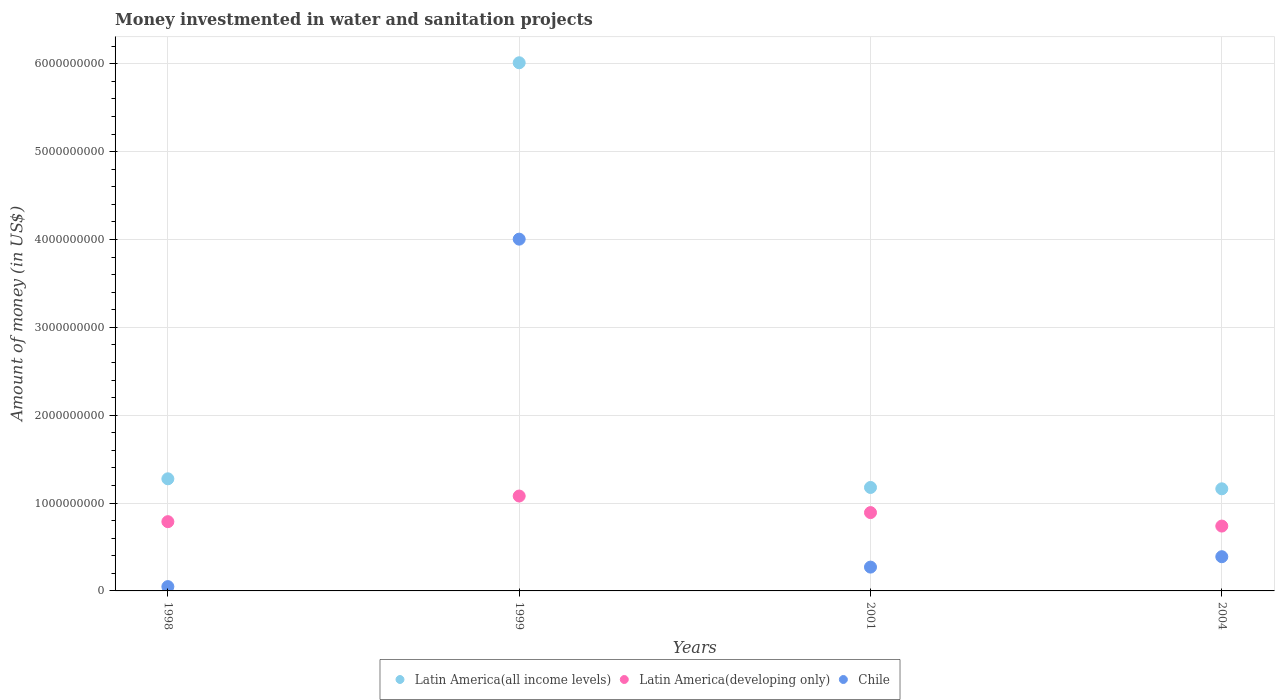How many different coloured dotlines are there?
Make the answer very short. 3. What is the money investmented in water and sanitation projects in Chile in 2001?
Your answer should be compact. 2.71e+08. Across all years, what is the maximum money investmented in water and sanitation projects in Latin America(developing only)?
Offer a very short reply. 1.08e+09. Across all years, what is the minimum money investmented in water and sanitation projects in Chile?
Keep it short and to the point. 4.90e+07. In which year was the money investmented in water and sanitation projects in Chile maximum?
Keep it short and to the point. 1999. In which year was the money investmented in water and sanitation projects in Latin America(all income levels) minimum?
Offer a very short reply. 2004. What is the total money investmented in water and sanitation projects in Latin America(all income levels) in the graph?
Keep it short and to the point. 9.63e+09. What is the difference between the money investmented in water and sanitation projects in Latin America(all income levels) in 1999 and that in 2004?
Provide a short and direct response. 4.85e+09. What is the difference between the money investmented in water and sanitation projects in Latin America(all income levels) in 2004 and the money investmented in water and sanitation projects in Chile in 2001?
Offer a terse response. 8.91e+08. What is the average money investmented in water and sanitation projects in Chile per year?
Provide a short and direct response. 1.18e+09. In the year 2004, what is the difference between the money investmented in water and sanitation projects in Chile and money investmented in water and sanitation projects in Latin America(all income levels)?
Offer a very short reply. -7.73e+08. In how many years, is the money investmented in water and sanitation projects in Latin America(developing only) greater than 6000000000 US$?
Offer a very short reply. 0. What is the ratio of the money investmented in water and sanitation projects in Latin America(developing only) in 2001 to that in 2004?
Keep it short and to the point. 1.21. What is the difference between the highest and the second highest money investmented in water and sanitation projects in Chile?
Offer a terse response. 3.61e+09. What is the difference between the highest and the lowest money investmented in water and sanitation projects in Chile?
Ensure brevity in your answer.  3.95e+09. In how many years, is the money investmented in water and sanitation projects in Latin America(developing only) greater than the average money investmented in water and sanitation projects in Latin America(developing only) taken over all years?
Your answer should be very brief. 2. Is the sum of the money investmented in water and sanitation projects in Latin America(all income levels) in 1999 and 2001 greater than the maximum money investmented in water and sanitation projects in Chile across all years?
Your answer should be very brief. Yes. Is the money investmented in water and sanitation projects in Latin America(developing only) strictly less than the money investmented in water and sanitation projects in Chile over the years?
Keep it short and to the point. No. How many dotlines are there?
Offer a very short reply. 3. What is the difference between two consecutive major ticks on the Y-axis?
Ensure brevity in your answer.  1.00e+09. Does the graph contain any zero values?
Make the answer very short. No. Does the graph contain grids?
Provide a short and direct response. Yes. Where does the legend appear in the graph?
Give a very brief answer. Bottom center. What is the title of the graph?
Provide a short and direct response. Money investmented in water and sanitation projects. What is the label or title of the X-axis?
Offer a very short reply. Years. What is the label or title of the Y-axis?
Make the answer very short. Amount of money (in US$). What is the Amount of money (in US$) of Latin America(all income levels) in 1998?
Provide a short and direct response. 1.28e+09. What is the Amount of money (in US$) of Latin America(developing only) in 1998?
Ensure brevity in your answer.  7.88e+08. What is the Amount of money (in US$) of Chile in 1998?
Offer a terse response. 4.90e+07. What is the Amount of money (in US$) in Latin America(all income levels) in 1999?
Keep it short and to the point. 6.01e+09. What is the Amount of money (in US$) in Latin America(developing only) in 1999?
Make the answer very short. 1.08e+09. What is the Amount of money (in US$) in Chile in 1999?
Offer a terse response. 4.00e+09. What is the Amount of money (in US$) in Latin America(all income levels) in 2001?
Offer a terse response. 1.18e+09. What is the Amount of money (in US$) in Latin America(developing only) in 2001?
Your response must be concise. 8.91e+08. What is the Amount of money (in US$) of Chile in 2001?
Give a very brief answer. 2.71e+08. What is the Amount of money (in US$) of Latin America(all income levels) in 2004?
Ensure brevity in your answer.  1.16e+09. What is the Amount of money (in US$) in Latin America(developing only) in 2004?
Provide a short and direct response. 7.38e+08. What is the Amount of money (in US$) of Chile in 2004?
Provide a succinct answer. 3.89e+08. Across all years, what is the maximum Amount of money (in US$) of Latin America(all income levels)?
Your answer should be very brief. 6.01e+09. Across all years, what is the maximum Amount of money (in US$) in Latin America(developing only)?
Your answer should be very brief. 1.08e+09. Across all years, what is the maximum Amount of money (in US$) of Chile?
Provide a short and direct response. 4.00e+09. Across all years, what is the minimum Amount of money (in US$) of Latin America(all income levels)?
Your answer should be very brief. 1.16e+09. Across all years, what is the minimum Amount of money (in US$) in Latin America(developing only)?
Make the answer very short. 7.38e+08. Across all years, what is the minimum Amount of money (in US$) of Chile?
Provide a short and direct response. 4.90e+07. What is the total Amount of money (in US$) of Latin America(all income levels) in the graph?
Your answer should be compact. 9.63e+09. What is the total Amount of money (in US$) of Latin America(developing only) in the graph?
Ensure brevity in your answer.  3.50e+09. What is the total Amount of money (in US$) in Chile in the graph?
Offer a terse response. 4.71e+09. What is the difference between the Amount of money (in US$) of Latin America(all income levels) in 1998 and that in 1999?
Ensure brevity in your answer.  -4.73e+09. What is the difference between the Amount of money (in US$) in Latin America(developing only) in 1998 and that in 1999?
Your answer should be compact. -2.92e+08. What is the difference between the Amount of money (in US$) of Chile in 1998 and that in 1999?
Offer a terse response. -3.95e+09. What is the difference between the Amount of money (in US$) in Latin America(all income levels) in 1998 and that in 2001?
Your response must be concise. 9.85e+07. What is the difference between the Amount of money (in US$) of Latin America(developing only) in 1998 and that in 2001?
Your answer should be compact. -1.03e+08. What is the difference between the Amount of money (in US$) in Chile in 1998 and that in 2001?
Give a very brief answer. -2.22e+08. What is the difference between the Amount of money (in US$) in Latin America(all income levels) in 1998 and that in 2004?
Offer a terse response. 1.14e+08. What is the difference between the Amount of money (in US$) in Latin America(developing only) in 1998 and that in 2004?
Provide a succinct answer. 5.01e+07. What is the difference between the Amount of money (in US$) of Chile in 1998 and that in 2004?
Offer a very short reply. -3.40e+08. What is the difference between the Amount of money (in US$) in Latin America(all income levels) in 1999 and that in 2001?
Your answer should be very brief. 4.83e+09. What is the difference between the Amount of money (in US$) in Latin America(developing only) in 1999 and that in 2001?
Offer a very short reply. 1.88e+08. What is the difference between the Amount of money (in US$) of Chile in 1999 and that in 2001?
Offer a very short reply. 3.73e+09. What is the difference between the Amount of money (in US$) in Latin America(all income levels) in 1999 and that in 2004?
Give a very brief answer. 4.85e+09. What is the difference between the Amount of money (in US$) in Latin America(developing only) in 1999 and that in 2004?
Your answer should be very brief. 3.42e+08. What is the difference between the Amount of money (in US$) in Chile in 1999 and that in 2004?
Make the answer very short. 3.61e+09. What is the difference between the Amount of money (in US$) of Latin America(all income levels) in 2001 and that in 2004?
Provide a succinct answer. 1.54e+07. What is the difference between the Amount of money (in US$) in Latin America(developing only) in 2001 and that in 2004?
Give a very brief answer. 1.53e+08. What is the difference between the Amount of money (in US$) in Chile in 2001 and that in 2004?
Your answer should be very brief. -1.18e+08. What is the difference between the Amount of money (in US$) in Latin America(all income levels) in 1998 and the Amount of money (in US$) in Latin America(developing only) in 1999?
Ensure brevity in your answer.  1.96e+08. What is the difference between the Amount of money (in US$) of Latin America(all income levels) in 1998 and the Amount of money (in US$) of Chile in 1999?
Give a very brief answer. -2.73e+09. What is the difference between the Amount of money (in US$) of Latin America(developing only) in 1998 and the Amount of money (in US$) of Chile in 1999?
Your response must be concise. -3.22e+09. What is the difference between the Amount of money (in US$) of Latin America(all income levels) in 1998 and the Amount of money (in US$) of Latin America(developing only) in 2001?
Ensure brevity in your answer.  3.84e+08. What is the difference between the Amount of money (in US$) of Latin America(all income levels) in 1998 and the Amount of money (in US$) of Chile in 2001?
Give a very brief answer. 1.00e+09. What is the difference between the Amount of money (in US$) in Latin America(developing only) in 1998 and the Amount of money (in US$) in Chile in 2001?
Offer a very short reply. 5.17e+08. What is the difference between the Amount of money (in US$) in Latin America(all income levels) in 1998 and the Amount of money (in US$) in Latin America(developing only) in 2004?
Your answer should be compact. 5.38e+08. What is the difference between the Amount of money (in US$) of Latin America(all income levels) in 1998 and the Amount of money (in US$) of Chile in 2004?
Ensure brevity in your answer.  8.86e+08. What is the difference between the Amount of money (in US$) of Latin America(developing only) in 1998 and the Amount of money (in US$) of Chile in 2004?
Offer a terse response. 3.99e+08. What is the difference between the Amount of money (in US$) of Latin America(all income levels) in 1999 and the Amount of money (in US$) of Latin America(developing only) in 2001?
Your response must be concise. 5.12e+09. What is the difference between the Amount of money (in US$) in Latin America(all income levels) in 1999 and the Amount of money (in US$) in Chile in 2001?
Make the answer very short. 5.74e+09. What is the difference between the Amount of money (in US$) of Latin America(developing only) in 1999 and the Amount of money (in US$) of Chile in 2001?
Provide a succinct answer. 8.09e+08. What is the difference between the Amount of money (in US$) of Latin America(all income levels) in 1999 and the Amount of money (in US$) of Latin America(developing only) in 2004?
Provide a short and direct response. 5.27e+09. What is the difference between the Amount of money (in US$) of Latin America(all income levels) in 1999 and the Amount of money (in US$) of Chile in 2004?
Keep it short and to the point. 5.62e+09. What is the difference between the Amount of money (in US$) of Latin America(developing only) in 1999 and the Amount of money (in US$) of Chile in 2004?
Give a very brief answer. 6.90e+08. What is the difference between the Amount of money (in US$) of Latin America(all income levels) in 2001 and the Amount of money (in US$) of Latin America(developing only) in 2004?
Your answer should be compact. 4.39e+08. What is the difference between the Amount of money (in US$) of Latin America(all income levels) in 2001 and the Amount of money (in US$) of Chile in 2004?
Your answer should be very brief. 7.88e+08. What is the difference between the Amount of money (in US$) of Latin America(developing only) in 2001 and the Amount of money (in US$) of Chile in 2004?
Provide a short and direct response. 5.02e+08. What is the average Amount of money (in US$) of Latin America(all income levels) per year?
Offer a terse response. 2.41e+09. What is the average Amount of money (in US$) in Latin America(developing only) per year?
Provide a short and direct response. 8.74e+08. What is the average Amount of money (in US$) of Chile per year?
Provide a succinct answer. 1.18e+09. In the year 1998, what is the difference between the Amount of money (in US$) of Latin America(all income levels) and Amount of money (in US$) of Latin America(developing only)?
Offer a terse response. 4.88e+08. In the year 1998, what is the difference between the Amount of money (in US$) of Latin America(all income levels) and Amount of money (in US$) of Chile?
Offer a very short reply. 1.23e+09. In the year 1998, what is the difference between the Amount of money (in US$) of Latin America(developing only) and Amount of money (in US$) of Chile?
Make the answer very short. 7.39e+08. In the year 1999, what is the difference between the Amount of money (in US$) of Latin America(all income levels) and Amount of money (in US$) of Latin America(developing only)?
Your answer should be compact. 4.93e+09. In the year 1999, what is the difference between the Amount of money (in US$) in Latin America(all income levels) and Amount of money (in US$) in Chile?
Ensure brevity in your answer.  2.01e+09. In the year 1999, what is the difference between the Amount of money (in US$) in Latin America(developing only) and Amount of money (in US$) in Chile?
Give a very brief answer. -2.92e+09. In the year 2001, what is the difference between the Amount of money (in US$) in Latin America(all income levels) and Amount of money (in US$) in Latin America(developing only)?
Your answer should be very brief. 2.86e+08. In the year 2001, what is the difference between the Amount of money (in US$) in Latin America(all income levels) and Amount of money (in US$) in Chile?
Provide a short and direct response. 9.06e+08. In the year 2001, what is the difference between the Amount of money (in US$) of Latin America(developing only) and Amount of money (in US$) of Chile?
Provide a short and direct response. 6.20e+08. In the year 2004, what is the difference between the Amount of money (in US$) of Latin America(all income levels) and Amount of money (in US$) of Latin America(developing only)?
Provide a succinct answer. 4.24e+08. In the year 2004, what is the difference between the Amount of money (in US$) of Latin America(all income levels) and Amount of money (in US$) of Chile?
Give a very brief answer. 7.73e+08. In the year 2004, what is the difference between the Amount of money (in US$) in Latin America(developing only) and Amount of money (in US$) in Chile?
Provide a succinct answer. 3.49e+08. What is the ratio of the Amount of money (in US$) in Latin America(all income levels) in 1998 to that in 1999?
Ensure brevity in your answer.  0.21. What is the ratio of the Amount of money (in US$) of Latin America(developing only) in 1998 to that in 1999?
Give a very brief answer. 0.73. What is the ratio of the Amount of money (in US$) of Chile in 1998 to that in 1999?
Make the answer very short. 0.01. What is the ratio of the Amount of money (in US$) of Latin America(all income levels) in 1998 to that in 2001?
Make the answer very short. 1.08. What is the ratio of the Amount of money (in US$) in Latin America(developing only) in 1998 to that in 2001?
Offer a terse response. 0.88. What is the ratio of the Amount of money (in US$) of Chile in 1998 to that in 2001?
Make the answer very short. 0.18. What is the ratio of the Amount of money (in US$) in Latin America(all income levels) in 1998 to that in 2004?
Ensure brevity in your answer.  1.1. What is the ratio of the Amount of money (in US$) in Latin America(developing only) in 1998 to that in 2004?
Your answer should be compact. 1.07. What is the ratio of the Amount of money (in US$) in Chile in 1998 to that in 2004?
Offer a very short reply. 0.13. What is the ratio of the Amount of money (in US$) in Latin America(all income levels) in 1999 to that in 2001?
Your response must be concise. 5.1. What is the ratio of the Amount of money (in US$) in Latin America(developing only) in 1999 to that in 2001?
Provide a short and direct response. 1.21. What is the ratio of the Amount of money (in US$) in Chile in 1999 to that in 2001?
Give a very brief answer. 14.77. What is the ratio of the Amount of money (in US$) in Latin America(all income levels) in 1999 to that in 2004?
Your answer should be very brief. 5.17. What is the ratio of the Amount of money (in US$) of Latin America(developing only) in 1999 to that in 2004?
Your answer should be compact. 1.46. What is the ratio of the Amount of money (in US$) of Chile in 1999 to that in 2004?
Give a very brief answer. 10.28. What is the ratio of the Amount of money (in US$) of Latin America(all income levels) in 2001 to that in 2004?
Your answer should be very brief. 1.01. What is the ratio of the Amount of money (in US$) of Latin America(developing only) in 2001 to that in 2004?
Ensure brevity in your answer.  1.21. What is the ratio of the Amount of money (in US$) of Chile in 2001 to that in 2004?
Keep it short and to the point. 0.7. What is the difference between the highest and the second highest Amount of money (in US$) of Latin America(all income levels)?
Ensure brevity in your answer.  4.73e+09. What is the difference between the highest and the second highest Amount of money (in US$) in Latin America(developing only)?
Ensure brevity in your answer.  1.88e+08. What is the difference between the highest and the second highest Amount of money (in US$) of Chile?
Offer a very short reply. 3.61e+09. What is the difference between the highest and the lowest Amount of money (in US$) in Latin America(all income levels)?
Give a very brief answer. 4.85e+09. What is the difference between the highest and the lowest Amount of money (in US$) in Latin America(developing only)?
Offer a terse response. 3.42e+08. What is the difference between the highest and the lowest Amount of money (in US$) in Chile?
Make the answer very short. 3.95e+09. 